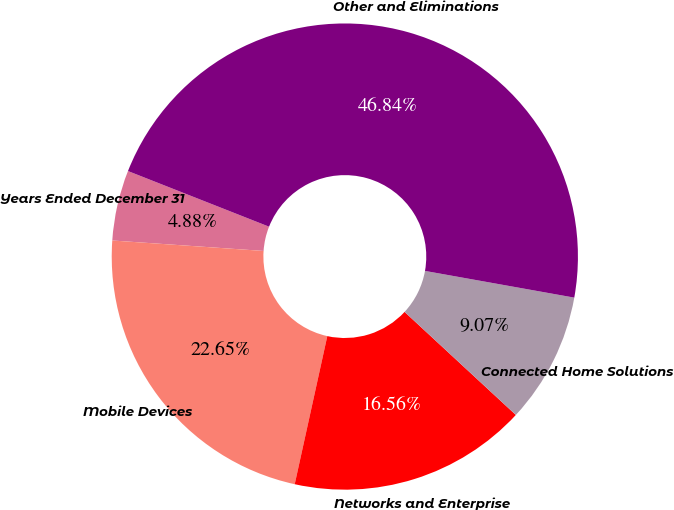<chart> <loc_0><loc_0><loc_500><loc_500><pie_chart><fcel>Years Ended December 31<fcel>Mobile Devices<fcel>Networks and Enterprise<fcel>Connected Home Solutions<fcel>Other and Eliminations<nl><fcel>4.88%<fcel>22.65%<fcel>16.56%<fcel>9.07%<fcel>46.84%<nl></chart> 